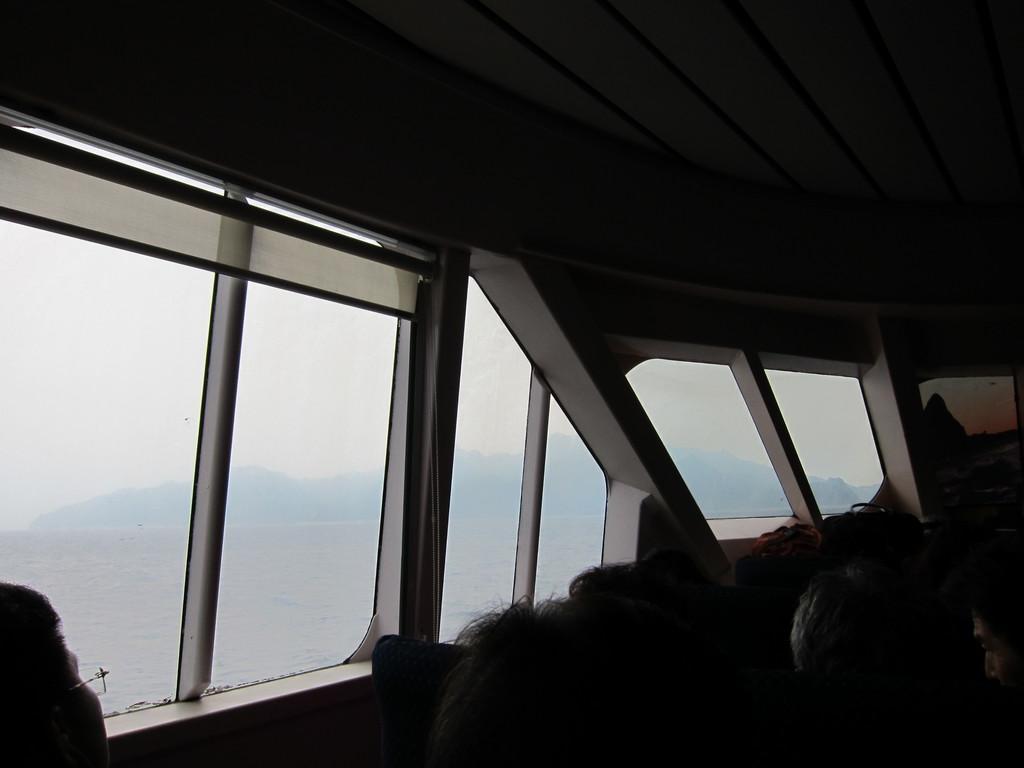How would you summarize this image in a sentence or two? In this picture there are people at the bottom side of the image and there are windows on the left side of the image. 